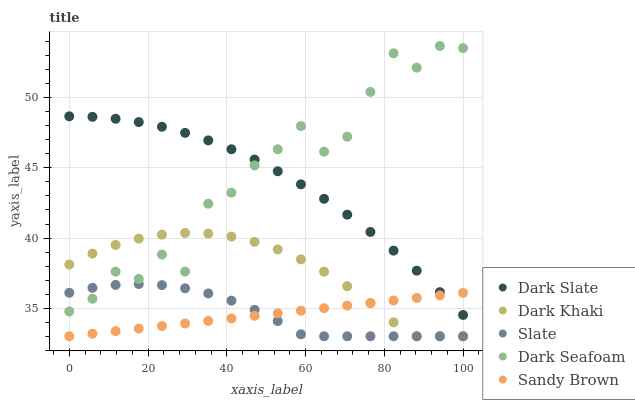Does Sandy Brown have the minimum area under the curve?
Answer yes or no. Yes. Does Dark Seafoam have the maximum area under the curve?
Answer yes or no. Yes. Does Dark Slate have the minimum area under the curve?
Answer yes or no. No. Does Dark Slate have the maximum area under the curve?
Answer yes or no. No. Is Sandy Brown the smoothest?
Answer yes or no. Yes. Is Dark Seafoam the roughest?
Answer yes or no. Yes. Is Dark Slate the smoothest?
Answer yes or no. No. Is Dark Slate the roughest?
Answer yes or no. No. Does Dark Khaki have the lowest value?
Answer yes or no. Yes. Does Dark Slate have the lowest value?
Answer yes or no. No. Does Dark Seafoam have the highest value?
Answer yes or no. Yes. Does Dark Slate have the highest value?
Answer yes or no. No. Is Dark Khaki less than Dark Slate?
Answer yes or no. Yes. Is Dark Slate greater than Slate?
Answer yes or no. Yes. Does Dark Khaki intersect Sandy Brown?
Answer yes or no. Yes. Is Dark Khaki less than Sandy Brown?
Answer yes or no. No. Is Dark Khaki greater than Sandy Brown?
Answer yes or no. No. Does Dark Khaki intersect Dark Slate?
Answer yes or no. No. 